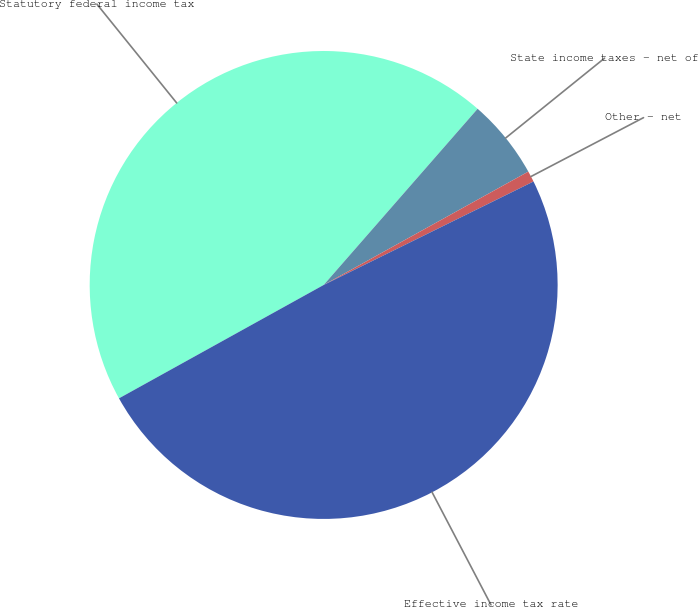<chart> <loc_0><loc_0><loc_500><loc_500><pie_chart><fcel>Statutory federal income tax<fcel>State income taxes - net of<fcel>Other - net<fcel>Effective income tax rate<nl><fcel>44.48%<fcel>5.52%<fcel>0.76%<fcel>49.24%<nl></chart> 